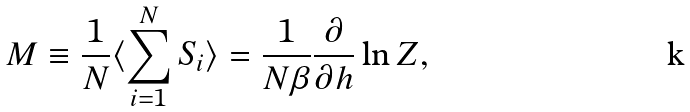Convert formula to latex. <formula><loc_0><loc_0><loc_500><loc_500>M \equiv \frac { 1 } { N } \langle \sum _ { i = 1 } ^ { N } S _ { i } \rangle = \frac { 1 } { N \beta } \frac { \partial } { \partial h } \ln Z ,</formula> 